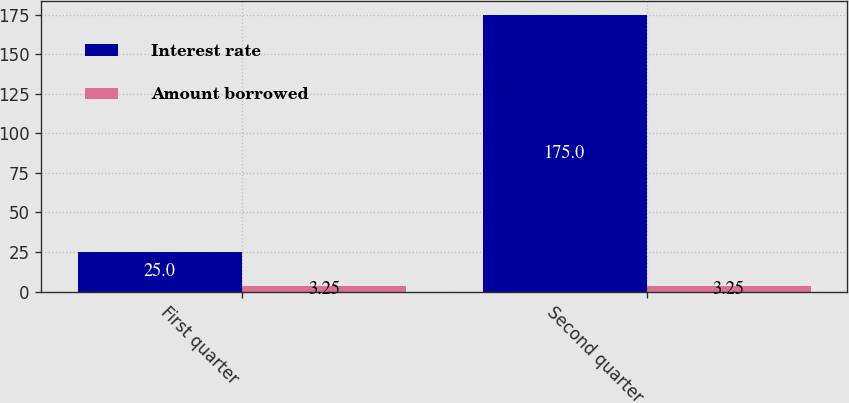Convert chart. <chart><loc_0><loc_0><loc_500><loc_500><stacked_bar_chart><ecel><fcel>First quarter<fcel>Second quarter<nl><fcel>Interest rate<fcel>25<fcel>175<nl><fcel>Amount borrowed<fcel>3.25<fcel>3.25<nl></chart> 